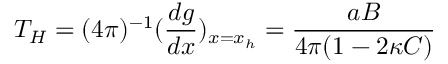Convert formula to latex. <formula><loc_0><loc_0><loc_500><loc_500>T _ { H } = ( 4 \pi ) ^ { - 1 } ( \frac { d g } { d x } ) _ { x = x _ { h } } = \frac { a B } { 4 \pi ( 1 - 2 \kappa C ) }</formula> 